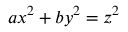Convert formula to latex. <formula><loc_0><loc_0><loc_500><loc_500>a x ^ { 2 } + b y ^ { 2 } = z ^ { 2 }</formula> 